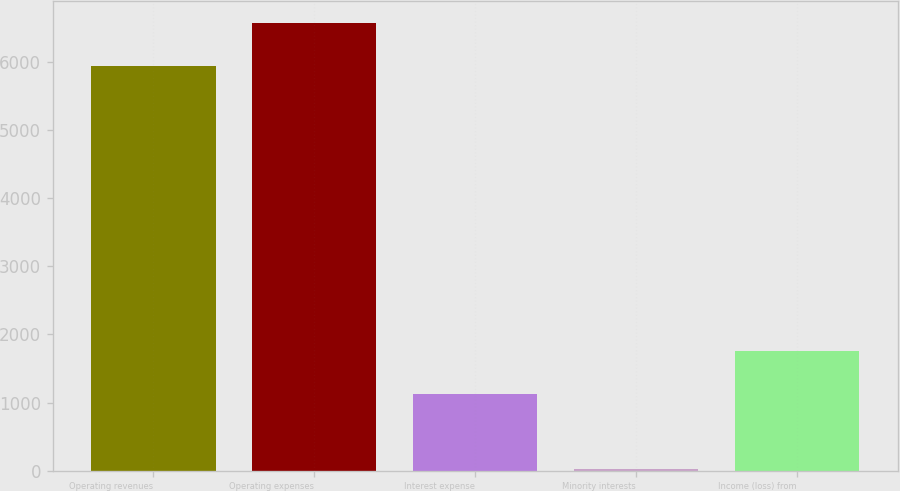<chart> <loc_0><loc_0><loc_500><loc_500><bar_chart><fcel>Operating revenues<fcel>Operating expenses<fcel>Interest expense<fcel>Minority interests<fcel>Income (loss) from<nl><fcel>5945<fcel>6566.6<fcel>1128<fcel>23<fcel>1749.6<nl></chart> 